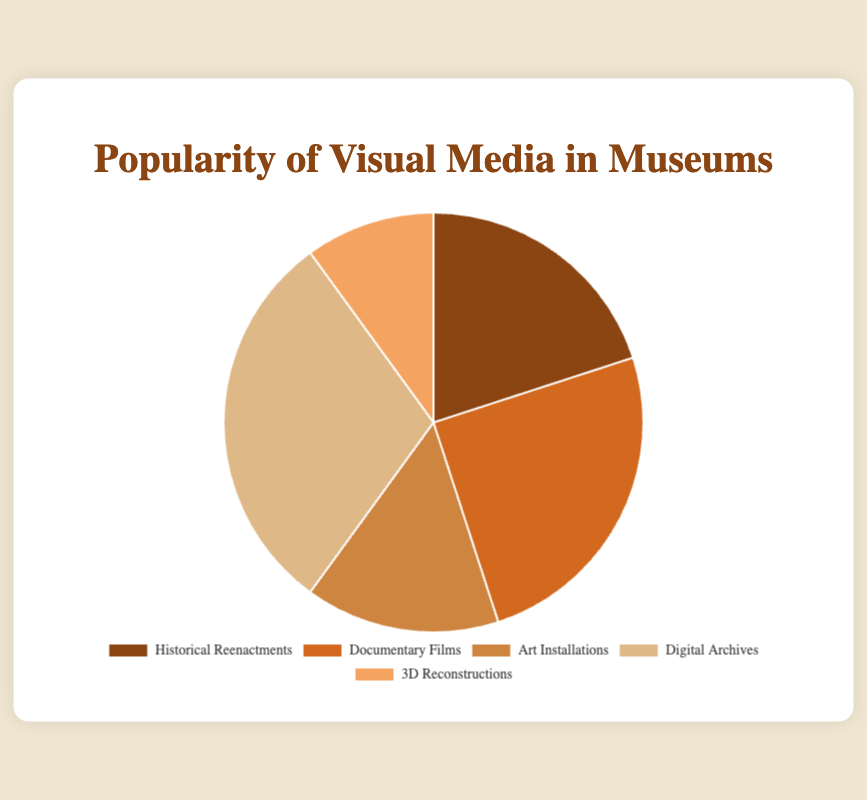What percentage of visitors prefer Digital Archives over Art Installations? Digital Archives have a popularity percentage of 30%, while Art Installations have a popularity percentage of 15%. The difference in popularity is 30% - 15% = 15%.
Answer: 15% Which visual media type is the most popular? According to the chart, Digital Archives have the highest popularity percentage at 30%, making it the most popular visual media type among the visitors.
Answer: Digital Archives Which media type has the smallest share of popularity? 3D Reconstructions have a popularity percentage of 10%, which is the smallest among the media types listed on the chart.
Answer: 3D Reconstructions What is the combined popularity percentage of Documentary Films and Historical Reenactments? Documentary Films have a popularity percentage of 25%, and Historical Reenactments have a popularity percentage of 20%. Their combined popularity is 25% + 20% = 45%.
Answer: 45% How much more popular are Documentary Films compared to 3D Reconstructions? The popularity percentage for Documentary Films is 25%, and for 3D Reconstructions, it is 10%. The difference is 25% - 10% = 15%.
Answer: 15% What is the total percentage of visitors' preferences for media types other than Art Installations? Art Installations account for 15%, so the other media types (100% - 15%) account for 85% in total.
Answer: 85% If we combine Historical Reenactments and 3D Reconstructions, would the combined percentage be more popular than Digital Archives? Historical Reenactments have 20% and 3D Reconstructions have 10%. Their combined percentage is 20% + 10% = 30%, which is equal to the popularity of Digital Archives.
Answer: No What percentage of the total does the most popular media type exceed the least popular one? The percentage difference between the most popular (Digital Archives at 30%) and least popular (3D Reconstructions at 10%) media is 30% - 10% = 20%.
Answer: 20% Which two media types combined would make up less than the popularity of Documentary Films? Art Installations (15%) and 3D Reconstructions (10%) combined make 15% + 10% = 25%, which is equal to, not less than, Documentary Films (25%). Alternatively, any other combination involving one higher percentage will exceed this value.
Answer: None 